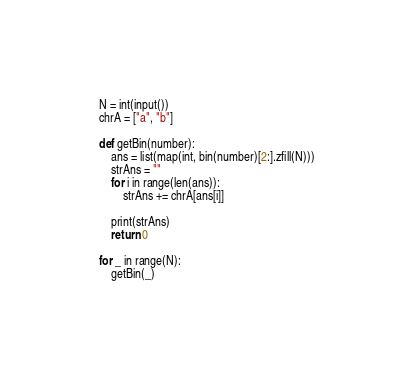Convert code to text. <code><loc_0><loc_0><loc_500><loc_500><_Python_>N = int(input())
chrA = ["a", "b"]

def getBin(number):
    ans = list(map(int, bin(number)[2:].zfill(N)))
    strAns = ""
    for i in range(len(ans)):
        strAns += chrA[ans[i]]

    print(strAns)
    return 0

for _ in range(N):
    getBin(_)
</code> 